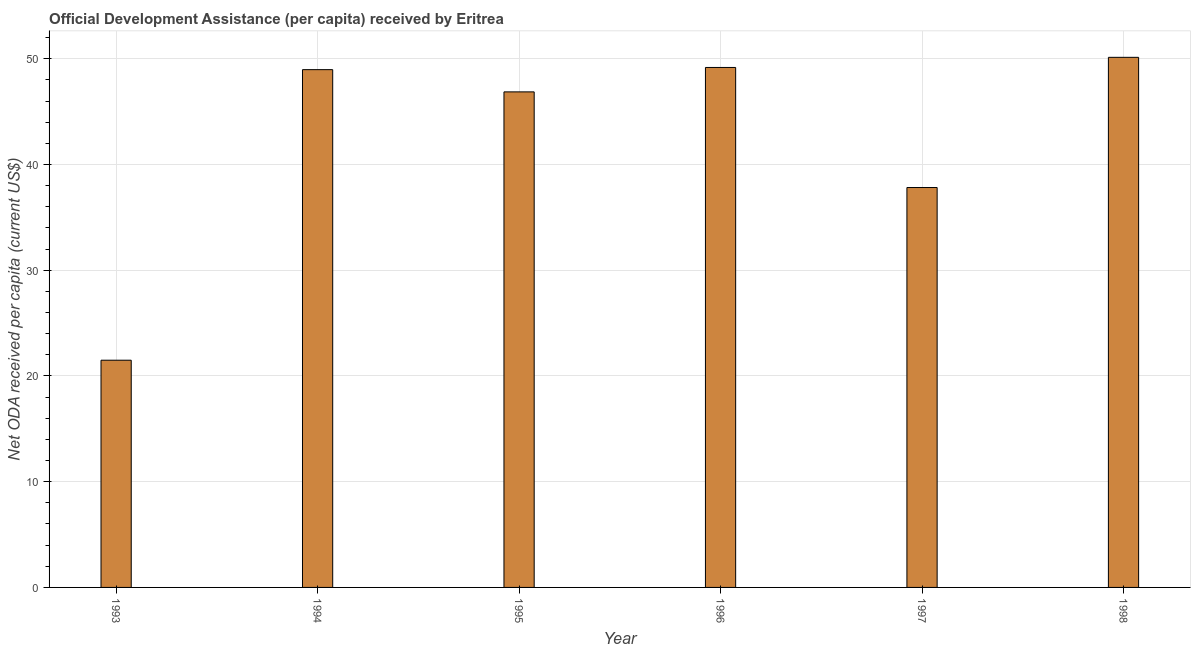What is the title of the graph?
Your answer should be very brief. Official Development Assistance (per capita) received by Eritrea. What is the label or title of the X-axis?
Give a very brief answer. Year. What is the label or title of the Y-axis?
Offer a very short reply. Net ODA received per capita (current US$). What is the net oda received per capita in 1997?
Provide a short and direct response. 37.82. Across all years, what is the maximum net oda received per capita?
Keep it short and to the point. 50.13. Across all years, what is the minimum net oda received per capita?
Give a very brief answer. 21.49. In which year was the net oda received per capita minimum?
Offer a very short reply. 1993. What is the sum of the net oda received per capita?
Make the answer very short. 254.46. What is the difference between the net oda received per capita in 1993 and 1994?
Give a very brief answer. -27.48. What is the average net oda received per capita per year?
Keep it short and to the point. 42.41. What is the median net oda received per capita?
Offer a terse response. 47.92. In how many years, is the net oda received per capita greater than 16 US$?
Your answer should be very brief. 6. Do a majority of the years between 1995 and 1996 (inclusive) have net oda received per capita greater than 30 US$?
Offer a terse response. Yes. What is the ratio of the net oda received per capita in 1995 to that in 1996?
Give a very brief answer. 0.95. What is the difference between the highest and the second highest net oda received per capita?
Your answer should be very brief. 0.96. Is the sum of the net oda received per capita in 1996 and 1997 greater than the maximum net oda received per capita across all years?
Make the answer very short. Yes. What is the difference between the highest and the lowest net oda received per capita?
Your response must be concise. 28.64. What is the Net ODA received per capita (current US$) in 1993?
Your answer should be compact. 21.49. What is the Net ODA received per capita (current US$) of 1994?
Give a very brief answer. 48.97. What is the Net ODA received per capita (current US$) of 1995?
Provide a short and direct response. 46.87. What is the Net ODA received per capita (current US$) in 1996?
Provide a succinct answer. 49.18. What is the Net ODA received per capita (current US$) in 1997?
Provide a succinct answer. 37.82. What is the Net ODA received per capita (current US$) in 1998?
Provide a succinct answer. 50.13. What is the difference between the Net ODA received per capita (current US$) in 1993 and 1994?
Provide a succinct answer. -27.48. What is the difference between the Net ODA received per capita (current US$) in 1993 and 1995?
Your answer should be very brief. -25.38. What is the difference between the Net ODA received per capita (current US$) in 1993 and 1996?
Offer a very short reply. -27.69. What is the difference between the Net ODA received per capita (current US$) in 1993 and 1997?
Ensure brevity in your answer.  -16.33. What is the difference between the Net ODA received per capita (current US$) in 1993 and 1998?
Keep it short and to the point. -28.64. What is the difference between the Net ODA received per capita (current US$) in 1994 and 1995?
Your response must be concise. 2.1. What is the difference between the Net ODA received per capita (current US$) in 1994 and 1996?
Offer a terse response. -0.21. What is the difference between the Net ODA received per capita (current US$) in 1994 and 1997?
Provide a short and direct response. 11.15. What is the difference between the Net ODA received per capita (current US$) in 1994 and 1998?
Give a very brief answer. -1.16. What is the difference between the Net ODA received per capita (current US$) in 1995 and 1996?
Make the answer very short. -2.31. What is the difference between the Net ODA received per capita (current US$) in 1995 and 1997?
Make the answer very short. 9.05. What is the difference between the Net ODA received per capita (current US$) in 1995 and 1998?
Ensure brevity in your answer.  -3.27. What is the difference between the Net ODA received per capita (current US$) in 1996 and 1997?
Keep it short and to the point. 11.35. What is the difference between the Net ODA received per capita (current US$) in 1996 and 1998?
Give a very brief answer. -0.96. What is the difference between the Net ODA received per capita (current US$) in 1997 and 1998?
Offer a very short reply. -12.31. What is the ratio of the Net ODA received per capita (current US$) in 1993 to that in 1994?
Offer a terse response. 0.44. What is the ratio of the Net ODA received per capita (current US$) in 1993 to that in 1995?
Provide a succinct answer. 0.46. What is the ratio of the Net ODA received per capita (current US$) in 1993 to that in 1996?
Your answer should be very brief. 0.44. What is the ratio of the Net ODA received per capita (current US$) in 1993 to that in 1997?
Offer a terse response. 0.57. What is the ratio of the Net ODA received per capita (current US$) in 1993 to that in 1998?
Offer a terse response. 0.43. What is the ratio of the Net ODA received per capita (current US$) in 1994 to that in 1995?
Ensure brevity in your answer.  1.04. What is the ratio of the Net ODA received per capita (current US$) in 1994 to that in 1996?
Your answer should be very brief. 1. What is the ratio of the Net ODA received per capita (current US$) in 1994 to that in 1997?
Your answer should be very brief. 1.29. What is the ratio of the Net ODA received per capita (current US$) in 1995 to that in 1996?
Give a very brief answer. 0.95. What is the ratio of the Net ODA received per capita (current US$) in 1995 to that in 1997?
Ensure brevity in your answer.  1.24. What is the ratio of the Net ODA received per capita (current US$) in 1995 to that in 1998?
Offer a very short reply. 0.94. What is the ratio of the Net ODA received per capita (current US$) in 1997 to that in 1998?
Your answer should be compact. 0.75. 